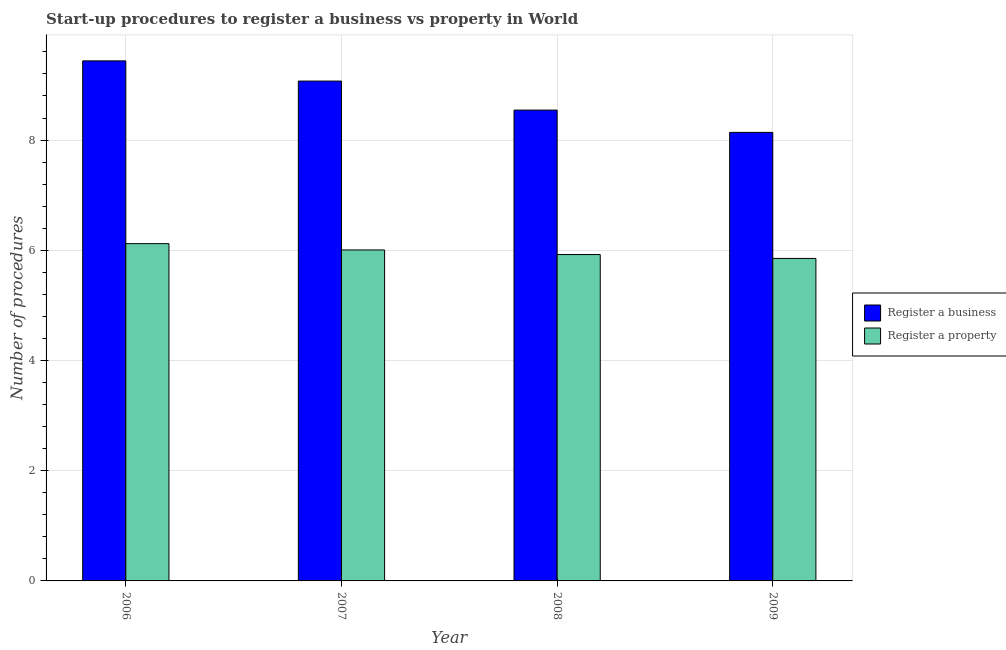How many different coloured bars are there?
Ensure brevity in your answer.  2. How many groups of bars are there?
Give a very brief answer. 4. Are the number of bars on each tick of the X-axis equal?
Offer a very short reply. Yes. How many bars are there on the 4th tick from the left?
Provide a succinct answer. 2. How many bars are there on the 3rd tick from the right?
Make the answer very short. 2. What is the number of procedures to register a property in 2009?
Make the answer very short. 5.85. Across all years, what is the maximum number of procedures to register a business?
Offer a terse response. 9.44. Across all years, what is the minimum number of procedures to register a business?
Your response must be concise. 8.14. In which year was the number of procedures to register a property minimum?
Your answer should be compact. 2009. What is the total number of procedures to register a property in the graph?
Give a very brief answer. 23.9. What is the difference between the number of procedures to register a property in 2007 and that in 2009?
Your answer should be very brief. 0.15. What is the difference between the number of procedures to register a business in 2008 and the number of procedures to register a property in 2007?
Keep it short and to the point. -0.53. What is the average number of procedures to register a property per year?
Provide a succinct answer. 5.98. What is the ratio of the number of procedures to register a business in 2007 to that in 2009?
Offer a very short reply. 1.11. What is the difference between the highest and the second highest number of procedures to register a property?
Your answer should be compact. 0.11. What is the difference between the highest and the lowest number of procedures to register a business?
Keep it short and to the point. 1.3. In how many years, is the number of procedures to register a property greater than the average number of procedures to register a property taken over all years?
Your response must be concise. 2. Is the sum of the number of procedures to register a business in 2008 and 2009 greater than the maximum number of procedures to register a property across all years?
Make the answer very short. Yes. What does the 1st bar from the left in 2009 represents?
Ensure brevity in your answer.  Register a business. What does the 2nd bar from the right in 2007 represents?
Your answer should be compact. Register a business. How many bars are there?
Make the answer very short. 8. Are all the bars in the graph horizontal?
Provide a succinct answer. No. How many years are there in the graph?
Ensure brevity in your answer.  4. What is the difference between two consecutive major ticks on the Y-axis?
Ensure brevity in your answer.  2. Are the values on the major ticks of Y-axis written in scientific E-notation?
Keep it short and to the point. No. Does the graph contain any zero values?
Your response must be concise. No. Where does the legend appear in the graph?
Your response must be concise. Center right. How many legend labels are there?
Provide a short and direct response. 2. How are the legend labels stacked?
Keep it short and to the point. Vertical. What is the title of the graph?
Ensure brevity in your answer.  Start-up procedures to register a business vs property in World. Does "Male labor force" appear as one of the legend labels in the graph?
Provide a succinct answer. No. What is the label or title of the Y-axis?
Ensure brevity in your answer.  Number of procedures. What is the Number of procedures of Register a business in 2006?
Your answer should be compact. 9.44. What is the Number of procedures of Register a property in 2006?
Offer a terse response. 6.12. What is the Number of procedures of Register a business in 2007?
Provide a short and direct response. 9.07. What is the Number of procedures in Register a property in 2007?
Offer a very short reply. 6.01. What is the Number of procedures of Register a business in 2008?
Provide a short and direct response. 8.54. What is the Number of procedures in Register a property in 2008?
Make the answer very short. 5.92. What is the Number of procedures in Register a business in 2009?
Your answer should be compact. 8.14. What is the Number of procedures of Register a property in 2009?
Offer a terse response. 5.85. Across all years, what is the maximum Number of procedures in Register a business?
Offer a very short reply. 9.44. Across all years, what is the maximum Number of procedures of Register a property?
Your answer should be very brief. 6.12. Across all years, what is the minimum Number of procedures of Register a business?
Ensure brevity in your answer.  8.14. Across all years, what is the minimum Number of procedures of Register a property?
Your answer should be very brief. 5.85. What is the total Number of procedures in Register a business in the graph?
Ensure brevity in your answer.  35.19. What is the total Number of procedures in Register a property in the graph?
Offer a very short reply. 23.9. What is the difference between the Number of procedures of Register a business in 2006 and that in 2007?
Provide a succinct answer. 0.37. What is the difference between the Number of procedures in Register a property in 2006 and that in 2007?
Your response must be concise. 0.11. What is the difference between the Number of procedures of Register a business in 2006 and that in 2008?
Your answer should be very brief. 0.89. What is the difference between the Number of procedures of Register a property in 2006 and that in 2008?
Your answer should be compact. 0.2. What is the difference between the Number of procedures in Register a business in 2006 and that in 2009?
Provide a succinct answer. 1.3. What is the difference between the Number of procedures in Register a property in 2006 and that in 2009?
Your answer should be very brief. 0.27. What is the difference between the Number of procedures of Register a business in 2007 and that in 2008?
Offer a very short reply. 0.53. What is the difference between the Number of procedures in Register a property in 2007 and that in 2008?
Keep it short and to the point. 0.08. What is the difference between the Number of procedures in Register a business in 2007 and that in 2009?
Ensure brevity in your answer.  0.93. What is the difference between the Number of procedures in Register a property in 2007 and that in 2009?
Your answer should be compact. 0.15. What is the difference between the Number of procedures in Register a business in 2008 and that in 2009?
Ensure brevity in your answer.  0.4. What is the difference between the Number of procedures in Register a property in 2008 and that in 2009?
Give a very brief answer. 0.07. What is the difference between the Number of procedures of Register a business in 2006 and the Number of procedures of Register a property in 2007?
Offer a very short reply. 3.43. What is the difference between the Number of procedures of Register a business in 2006 and the Number of procedures of Register a property in 2008?
Give a very brief answer. 3.51. What is the difference between the Number of procedures in Register a business in 2006 and the Number of procedures in Register a property in 2009?
Offer a very short reply. 3.59. What is the difference between the Number of procedures in Register a business in 2007 and the Number of procedures in Register a property in 2008?
Your answer should be very brief. 3.15. What is the difference between the Number of procedures in Register a business in 2007 and the Number of procedures in Register a property in 2009?
Offer a terse response. 3.22. What is the difference between the Number of procedures of Register a business in 2008 and the Number of procedures of Register a property in 2009?
Your response must be concise. 2.69. What is the average Number of procedures in Register a business per year?
Your response must be concise. 8.8. What is the average Number of procedures of Register a property per year?
Your answer should be very brief. 5.98. In the year 2006, what is the difference between the Number of procedures in Register a business and Number of procedures in Register a property?
Offer a terse response. 3.32. In the year 2007, what is the difference between the Number of procedures in Register a business and Number of procedures in Register a property?
Give a very brief answer. 3.06. In the year 2008, what is the difference between the Number of procedures of Register a business and Number of procedures of Register a property?
Give a very brief answer. 2.62. In the year 2009, what is the difference between the Number of procedures in Register a business and Number of procedures in Register a property?
Provide a succinct answer. 2.29. What is the ratio of the Number of procedures of Register a business in 2006 to that in 2007?
Provide a succinct answer. 1.04. What is the ratio of the Number of procedures in Register a property in 2006 to that in 2007?
Keep it short and to the point. 1.02. What is the ratio of the Number of procedures in Register a business in 2006 to that in 2008?
Offer a very short reply. 1.1. What is the ratio of the Number of procedures in Register a property in 2006 to that in 2008?
Your answer should be very brief. 1.03. What is the ratio of the Number of procedures in Register a business in 2006 to that in 2009?
Keep it short and to the point. 1.16. What is the ratio of the Number of procedures of Register a property in 2006 to that in 2009?
Your response must be concise. 1.05. What is the ratio of the Number of procedures of Register a business in 2007 to that in 2008?
Keep it short and to the point. 1.06. What is the ratio of the Number of procedures of Register a property in 2007 to that in 2008?
Keep it short and to the point. 1.01. What is the ratio of the Number of procedures in Register a business in 2007 to that in 2009?
Keep it short and to the point. 1.11. What is the ratio of the Number of procedures of Register a property in 2007 to that in 2009?
Ensure brevity in your answer.  1.03. What is the ratio of the Number of procedures in Register a business in 2008 to that in 2009?
Ensure brevity in your answer.  1.05. What is the ratio of the Number of procedures in Register a property in 2008 to that in 2009?
Offer a very short reply. 1.01. What is the difference between the highest and the second highest Number of procedures of Register a business?
Provide a short and direct response. 0.37. What is the difference between the highest and the second highest Number of procedures of Register a property?
Offer a terse response. 0.11. What is the difference between the highest and the lowest Number of procedures in Register a business?
Provide a succinct answer. 1.3. What is the difference between the highest and the lowest Number of procedures of Register a property?
Your answer should be compact. 0.27. 